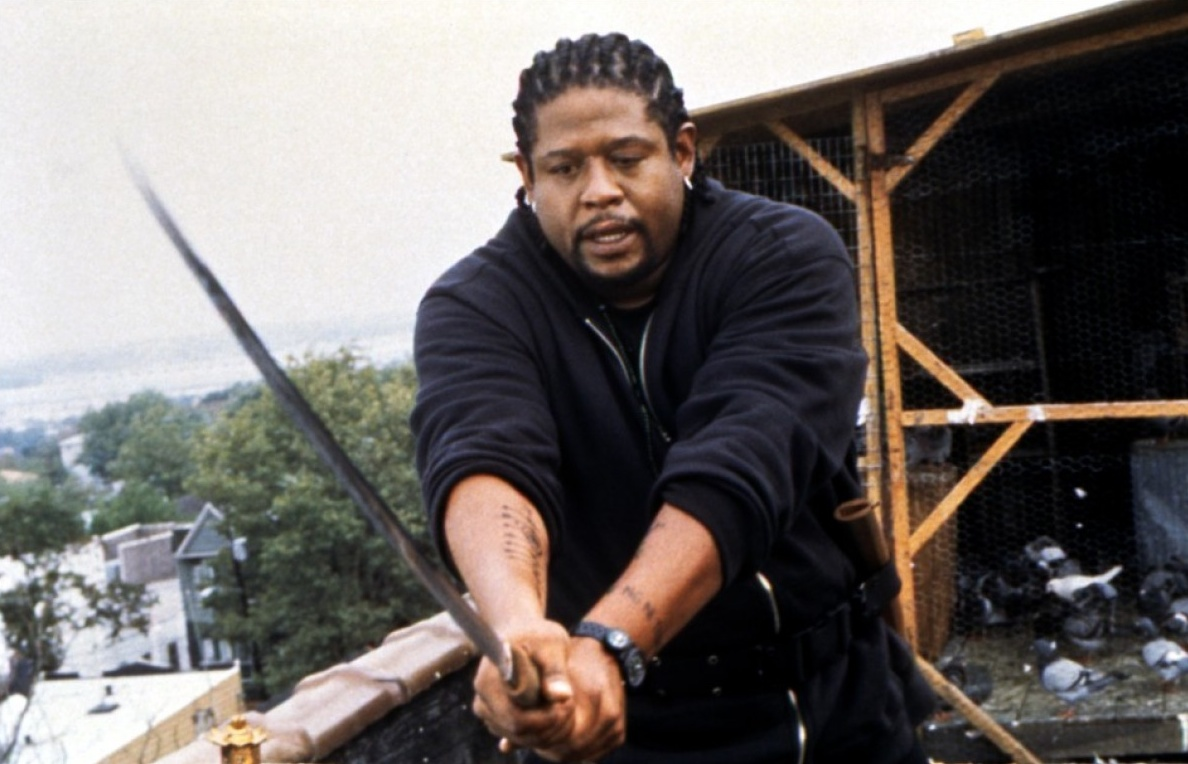Imagine and describe what happens next in this scene. As the scene progresses, the character tightens their grip on the sword, taking a defensive stance. Suddenly, another figure emerges from the shadows on the rooftop, equally armed and ready for battle. The two engage in a fierce exchange of blows, their swords clashing with intense precision. The sound of metal echoing across the buildings draws the attention of those below. The pigeons flutter away, startled by the commotion. The fight reaches its climax when one character makes a surprising move, outmaneuvering the other, leading to a dramatic turn of events that leaves the viewer on the edge of their seat, anticipating what will happen next. 